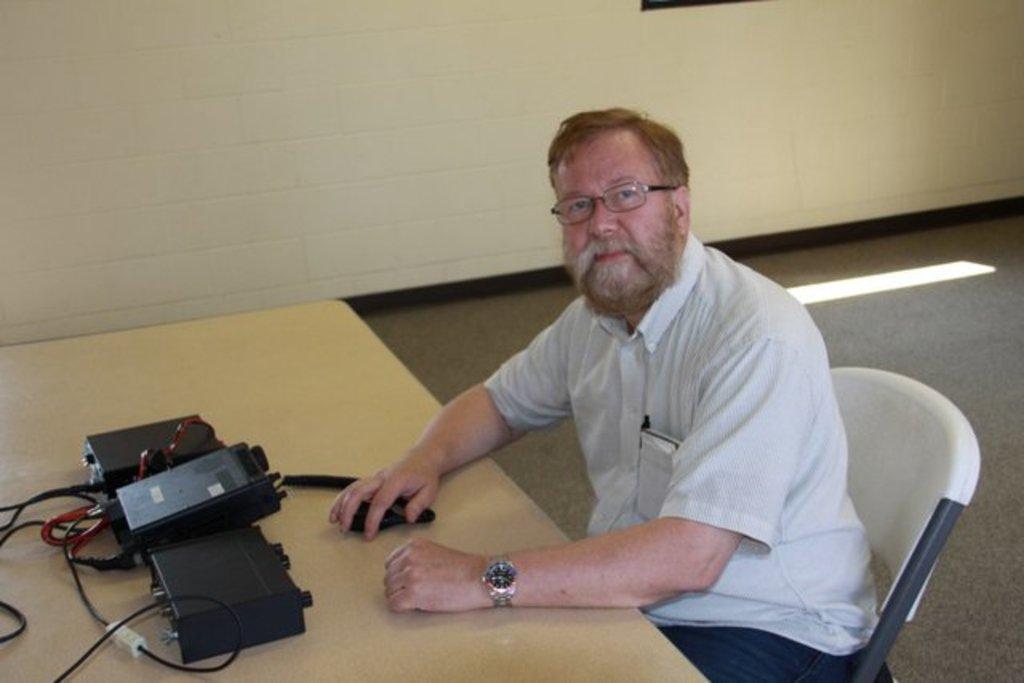Could you give a brief overview of what you see in this image? In the picture we can see a man sitting on the chair near the table on it, we can see an electronic device which is black in color with wires and in the background we can see a wall. 